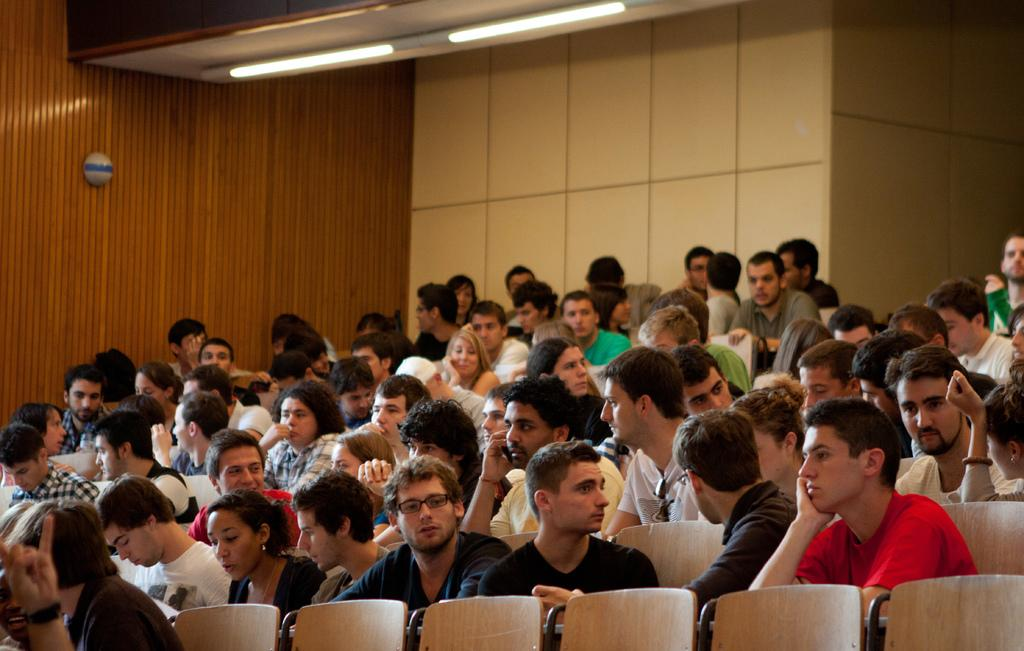How many people are in the image? There are multiple persons in the image. What are the persons doing in the image? The persons are sitting on chairs. What is the color of the background in the image? The background of the image is white. What type of smoke can be seen coming from the clocks in the image? There are no clocks or smoke present in the image. 